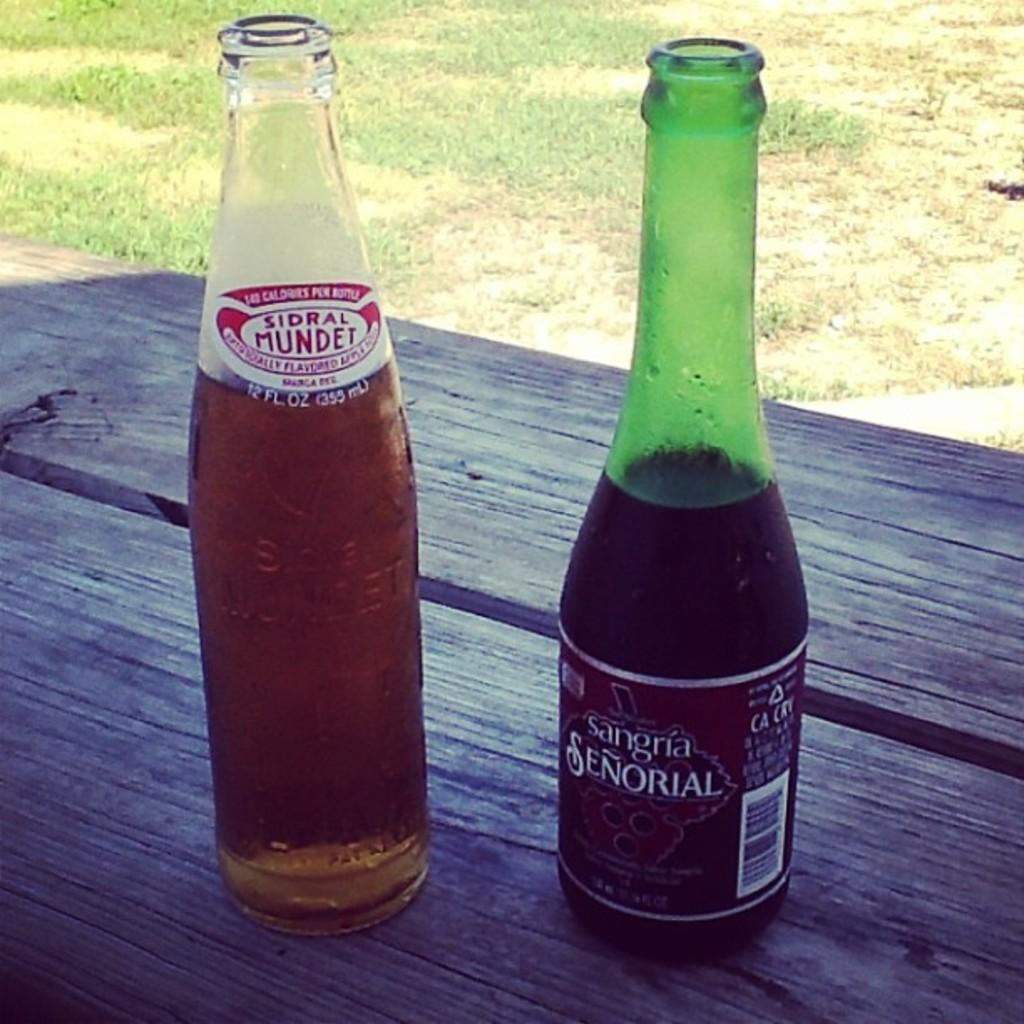<image>
Share a concise interpretation of the image provided. A bottle of Sangria Senorial sits next to a bottle of Sidral Mundet. 